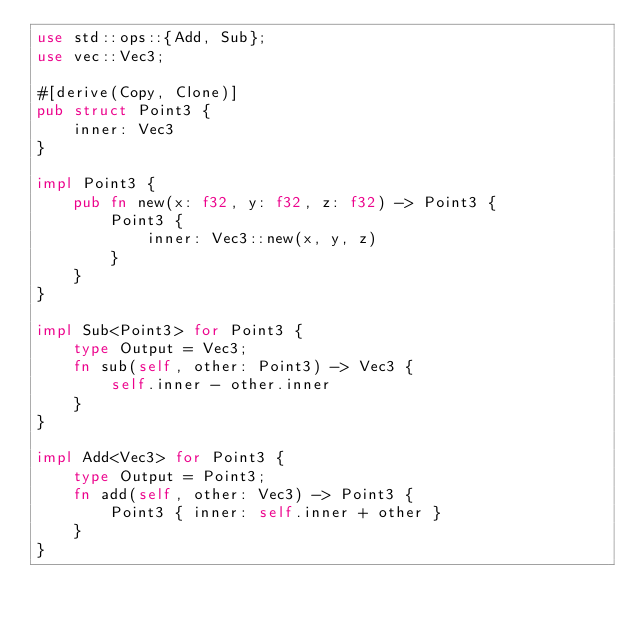<code> <loc_0><loc_0><loc_500><loc_500><_Rust_>use std::ops::{Add, Sub};
use vec::Vec3;

#[derive(Copy, Clone)]
pub struct Point3 {
    inner: Vec3
}

impl Point3 {
	pub fn new(x: f32, y: f32, z: f32) -> Point3 {
		Point3 {
			inner: Vec3::new(x, y, z)
		}
	}
}

impl Sub<Point3> for Point3 {
    type Output = Vec3;
    fn sub(self, other: Point3) -> Vec3 {
        self.inner - other.inner
    }
}

impl Add<Vec3> for Point3 {
    type Output = Point3;
    fn add(self, other: Vec3) -> Point3 {
        Point3 { inner: self.inner + other }
    }
}
</code> 